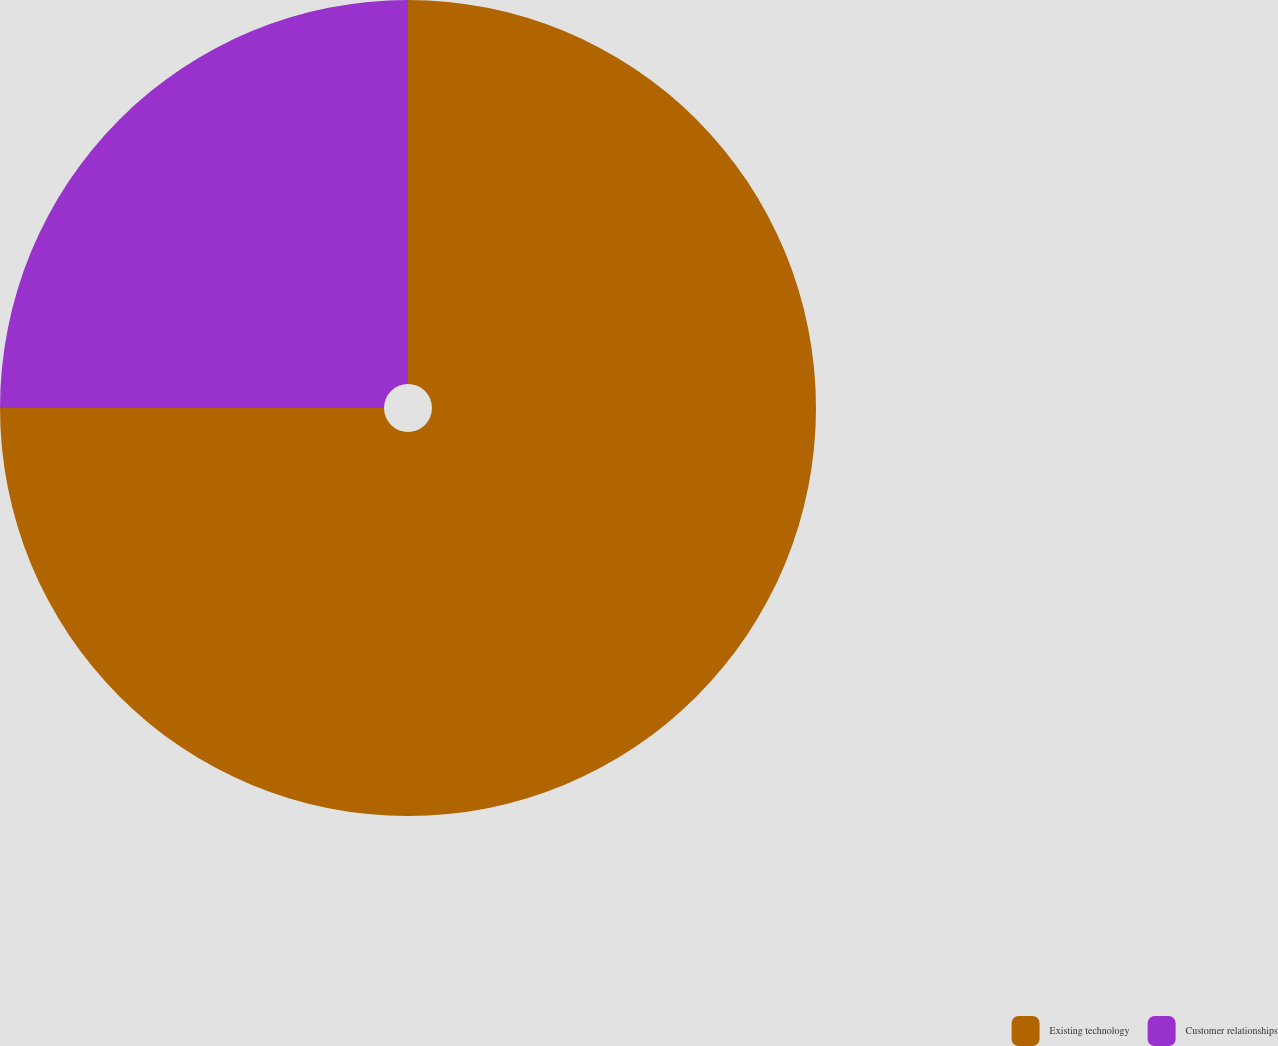<chart> <loc_0><loc_0><loc_500><loc_500><pie_chart><fcel>Existing technology<fcel>Customer relationships<nl><fcel>75.0%<fcel>25.0%<nl></chart> 